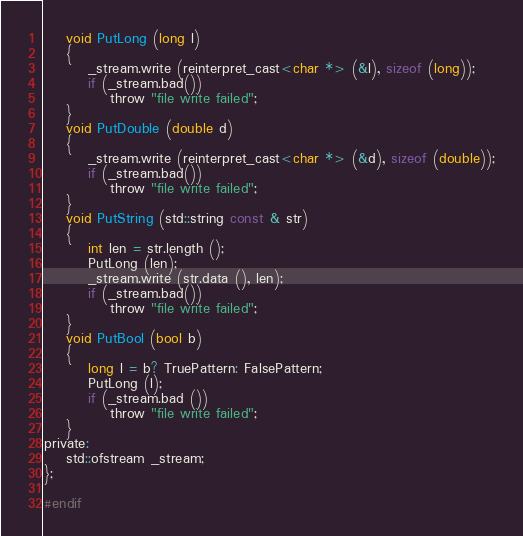Convert code to text. <code><loc_0><loc_0><loc_500><loc_500><_C_>    void PutLong (long l)
    {
        _stream.write (reinterpret_cast<char *> (&l), sizeof (long));
        if (_stream.bad())
            throw "file write failed";
    }
    void PutDouble (double d)
    {
        _stream.write (reinterpret_cast<char *> (&d), sizeof (double));
        if (_stream.bad())
            throw "file write failed";
    }
    void PutString (std::string const & str)
    {
		int len = str.length ();
        PutLong (len);
        _stream.write (str.data (), len);
        if (_stream.bad())
            throw "file write failed";
    }
	void PutBool (bool b)
	{
		long l = b? TruePattern: FalsePattern;
		PutLong (l);
        if (_stream.bad ())
            throw "file write failed";
	}
private:
	std::ofstream _stream;
};

#endif</code> 